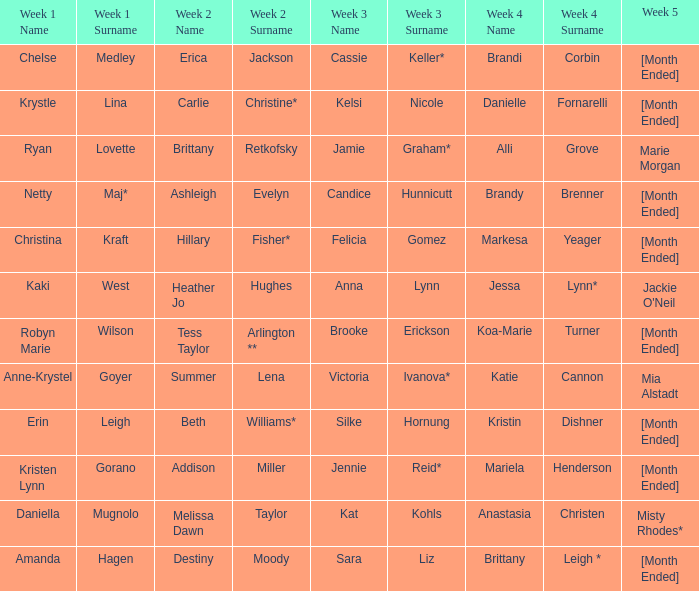What is the week 2 with daniella mugnolo in week 1? Melissa Dawn Taylor. 